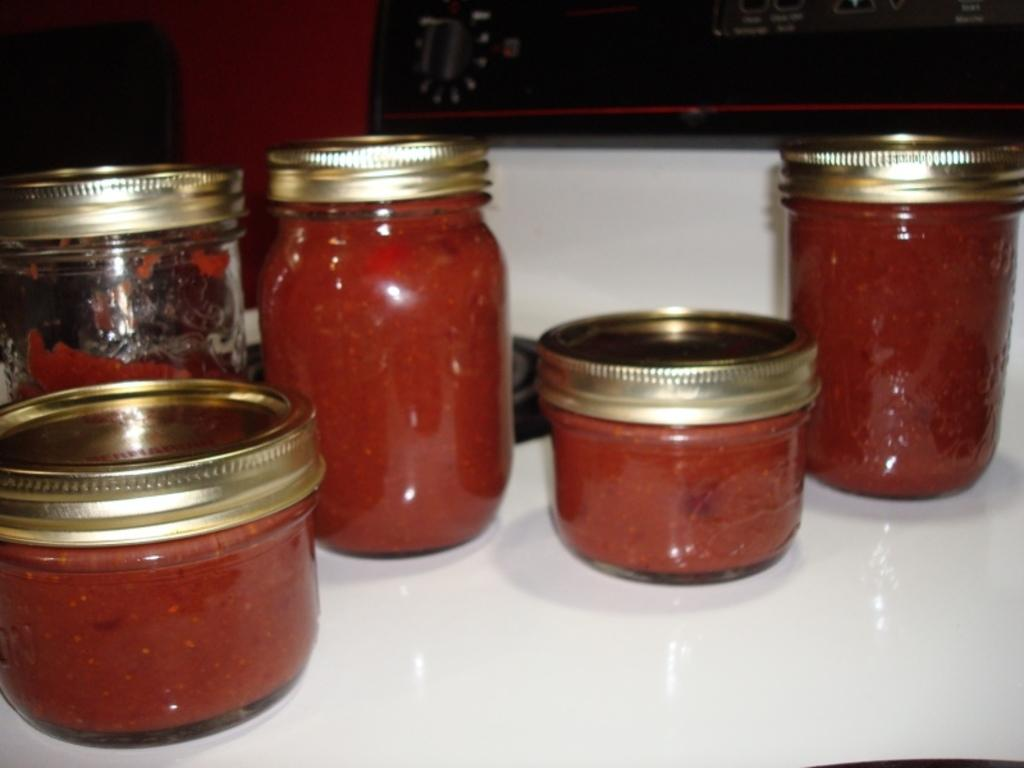What type of containers are used to store food items in the image? There are glass jars with food items in the image. What kind of food items are stored in the glass jars? The glass jars contain kids, which might refer to candy or snacks. Where are the glass jars placed in the image? The glass jars are placed on a whiteboard. Can you describe the object in the background of the image? Unfortunately, the provided facts do not give enough information to describe the object in the background. What type of engine is used to power the glass jars in the image? There is no engine present in the image, as the glass jars are containers for food items and not a machine or vehicle. 